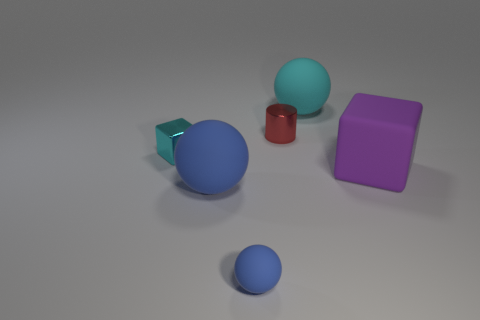Add 3 tiny rubber objects. How many objects exist? 9 Subtract all large spheres. How many spheres are left? 1 Subtract all cylinders. How many objects are left? 5 Add 2 cylinders. How many cylinders exist? 3 Subtract 0 green cylinders. How many objects are left? 6 Subtract all big rubber spheres. Subtract all small things. How many objects are left? 1 Add 6 metal cubes. How many metal cubes are left? 7 